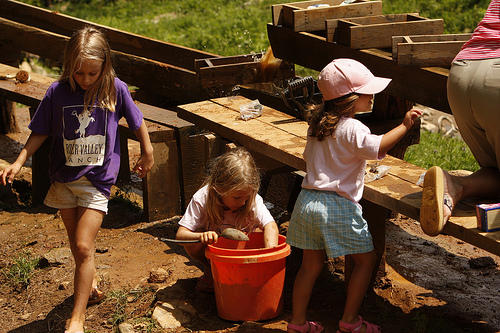<image>
Is the child next to the children? Yes. The child is positioned adjacent to the children, located nearby in the same general area. 